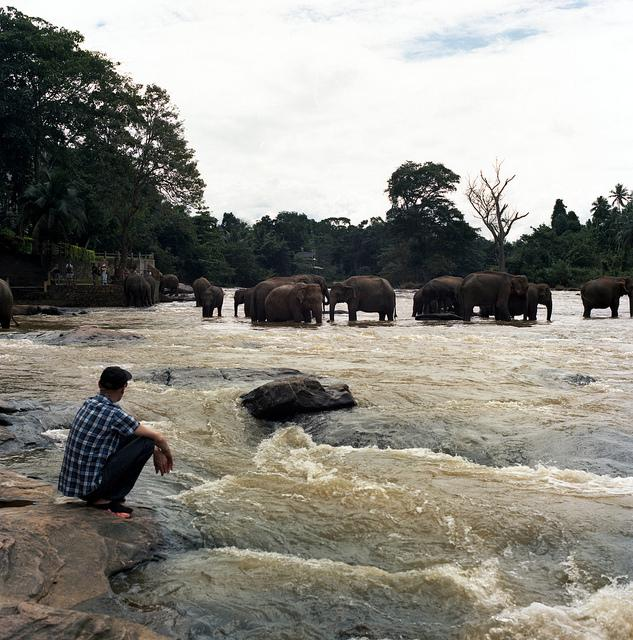What poses the greatest immediate danger to the man? Please explain your reasoning. waves. Since the elephants are not listed and there are no spiders or tigers around, it would be the waves. the water seems to be moving a lot, which could drag him away. 